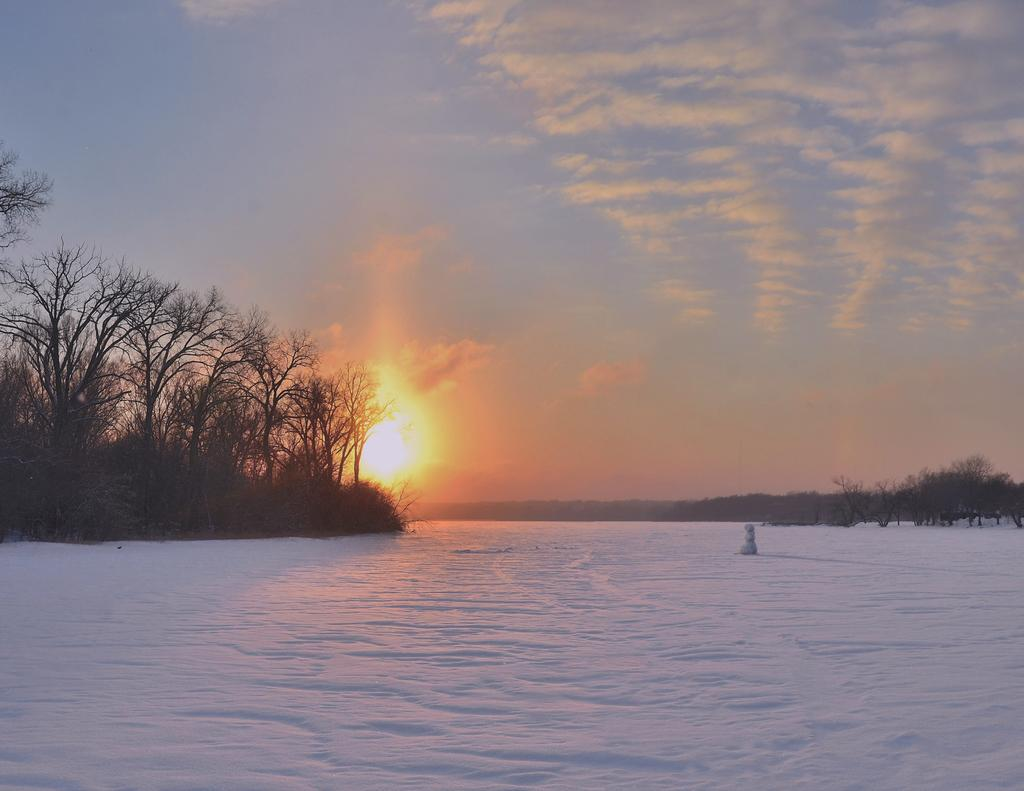What is the main subject of the image? There is a snowman in the image. Where is the snowman located? The snowman is placed on the ground. What is the condition of the ground in the image? The ground is covered with snow. What type of vegetation can be seen in the image? There is a group of trees in the image. What geographical features are visible in the image? The hills are visible in the image. What celestial body is present in the image? The sun is present in the image. How would you describe the sky in the image? The sky looks cloudy. What type of butter is being used to create the fog in the image? There is no butter or fog present in the image; it features a snowman, trees, hills, and a cloudy sky. 